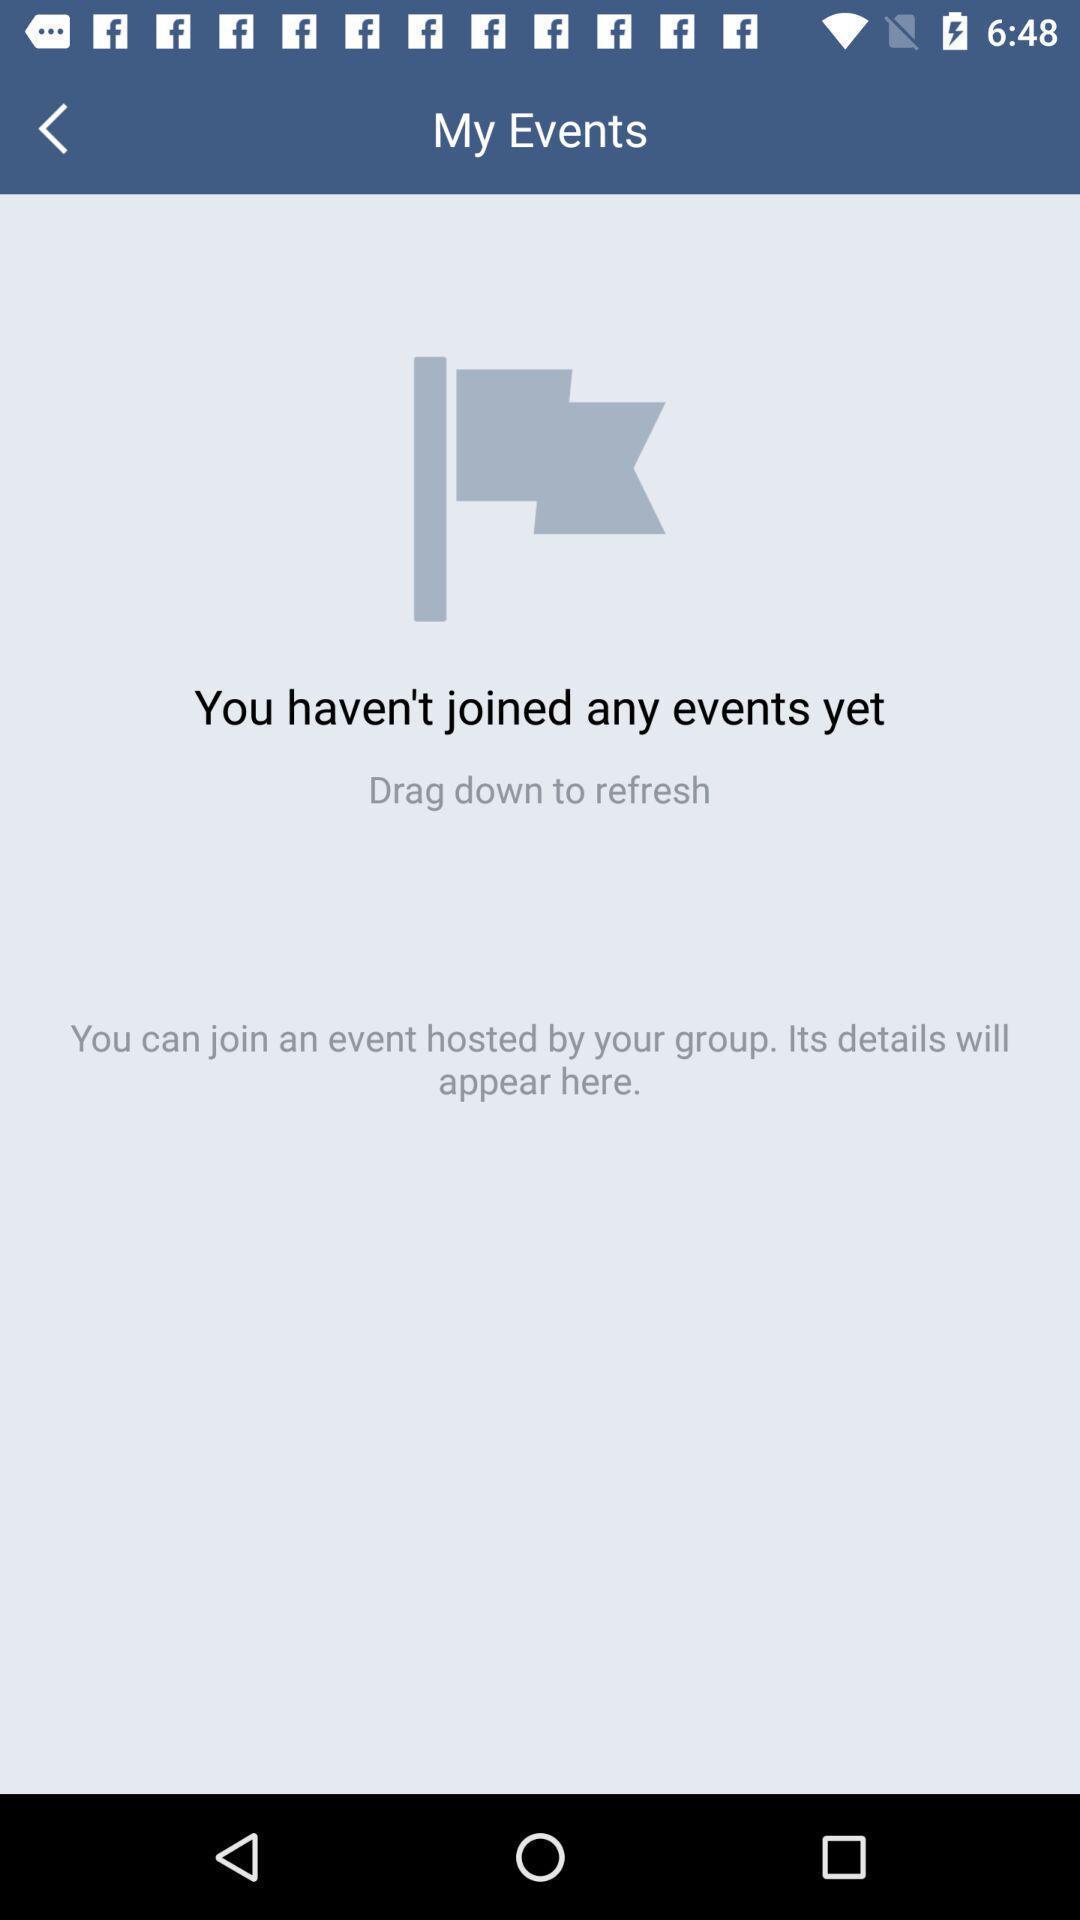Explain what's happening in this screen capture. Page showing you have n't joined any events yet in application. 